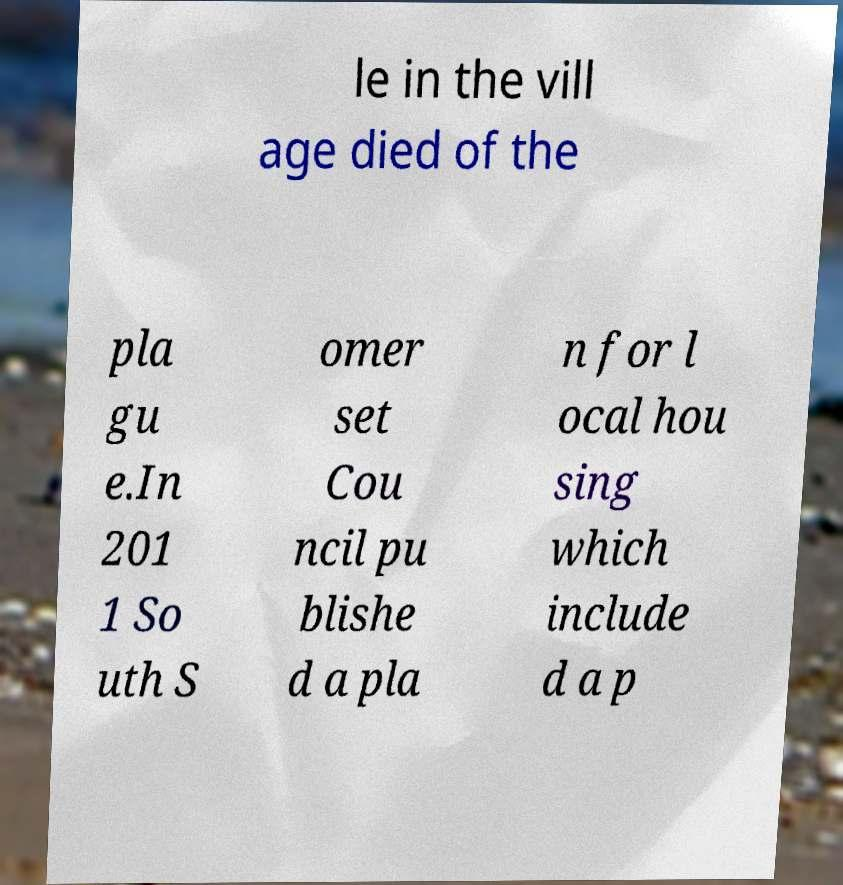For documentation purposes, I need the text within this image transcribed. Could you provide that? le in the vill age died of the pla gu e.In 201 1 So uth S omer set Cou ncil pu blishe d a pla n for l ocal hou sing which include d a p 